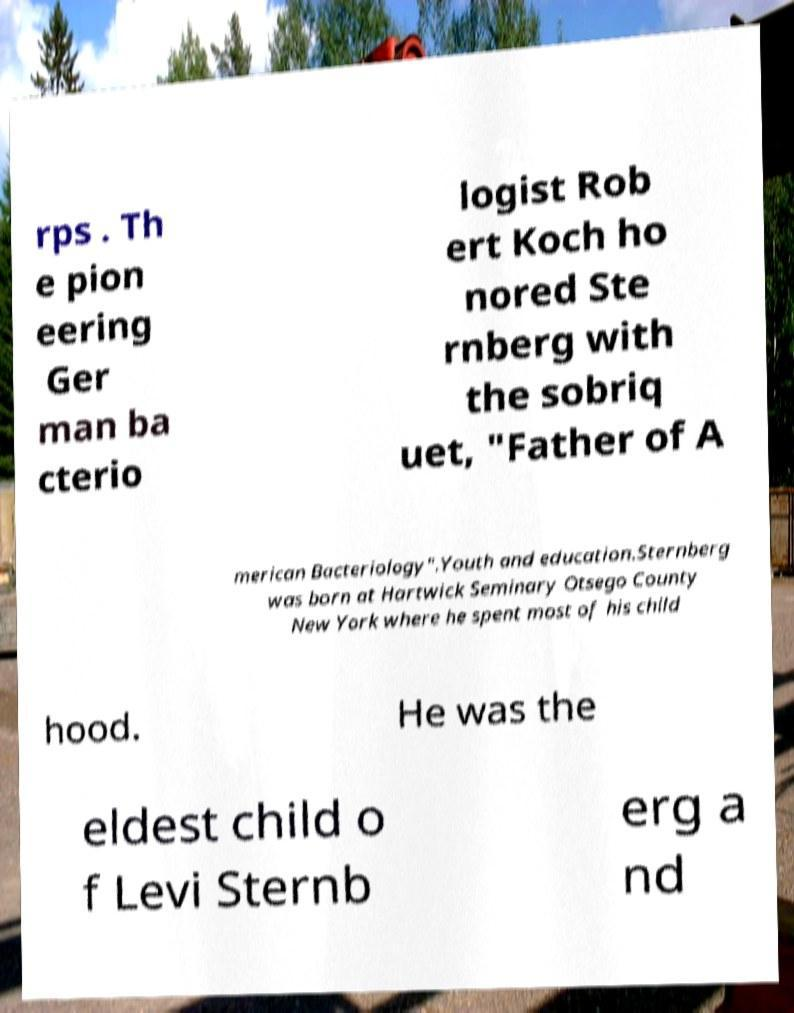Please identify and transcribe the text found in this image. rps . Th e pion eering Ger man ba cterio logist Rob ert Koch ho nored Ste rnberg with the sobriq uet, "Father of A merican Bacteriology".Youth and education.Sternberg was born at Hartwick Seminary Otsego County New York where he spent most of his child hood. He was the eldest child o f Levi Sternb erg a nd 